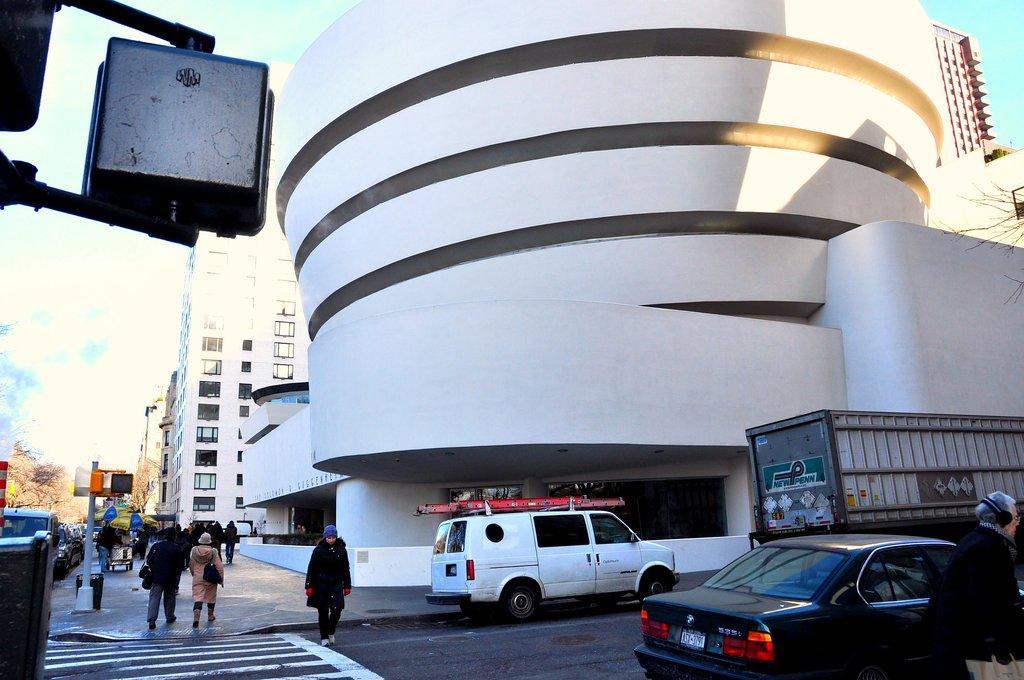How would you summarize this image in a sentence or two? In this image there are vehicles, trees in the left corner. There are vehicles, personal and buildings in the right corner. There are people, vehicles, buildings and pole in the foreground. There is a sky at the top. And there is a road at the bottom. 